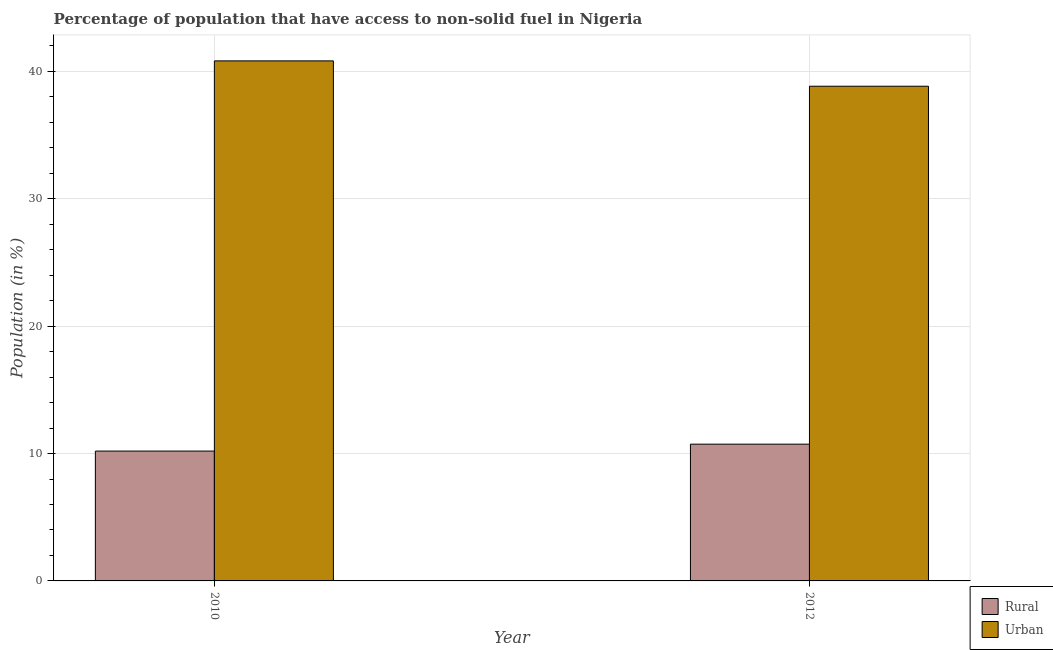How many groups of bars are there?
Your response must be concise. 2. Are the number of bars on each tick of the X-axis equal?
Ensure brevity in your answer.  Yes. In how many cases, is the number of bars for a given year not equal to the number of legend labels?
Keep it short and to the point. 0. What is the urban population in 2010?
Your response must be concise. 40.82. Across all years, what is the maximum rural population?
Give a very brief answer. 10.73. Across all years, what is the minimum urban population?
Make the answer very short. 38.83. What is the total rural population in the graph?
Offer a terse response. 20.93. What is the difference between the rural population in 2010 and that in 2012?
Give a very brief answer. -0.54. What is the difference between the rural population in 2012 and the urban population in 2010?
Provide a succinct answer. 0.54. What is the average urban population per year?
Offer a very short reply. 39.83. What is the ratio of the urban population in 2010 to that in 2012?
Provide a succinct answer. 1.05. Is the urban population in 2010 less than that in 2012?
Provide a succinct answer. No. In how many years, is the urban population greater than the average urban population taken over all years?
Provide a short and direct response. 1. What does the 2nd bar from the left in 2012 represents?
Keep it short and to the point. Urban. What does the 1st bar from the right in 2010 represents?
Your answer should be very brief. Urban. What is the difference between two consecutive major ticks on the Y-axis?
Your answer should be compact. 10. Are the values on the major ticks of Y-axis written in scientific E-notation?
Ensure brevity in your answer.  No. Does the graph contain any zero values?
Provide a short and direct response. No. Does the graph contain grids?
Make the answer very short. Yes. Where does the legend appear in the graph?
Your response must be concise. Bottom right. How many legend labels are there?
Make the answer very short. 2. How are the legend labels stacked?
Offer a terse response. Vertical. What is the title of the graph?
Keep it short and to the point. Percentage of population that have access to non-solid fuel in Nigeria. What is the label or title of the X-axis?
Offer a terse response. Year. What is the label or title of the Y-axis?
Keep it short and to the point. Population (in %). What is the Population (in %) in Rural in 2010?
Your answer should be very brief. 10.19. What is the Population (in %) in Urban in 2010?
Your answer should be very brief. 40.82. What is the Population (in %) of Rural in 2012?
Your answer should be compact. 10.73. What is the Population (in %) of Urban in 2012?
Provide a succinct answer. 38.83. Across all years, what is the maximum Population (in %) of Rural?
Offer a terse response. 10.73. Across all years, what is the maximum Population (in %) in Urban?
Keep it short and to the point. 40.82. Across all years, what is the minimum Population (in %) in Rural?
Ensure brevity in your answer.  10.19. Across all years, what is the minimum Population (in %) of Urban?
Make the answer very short. 38.83. What is the total Population (in %) in Rural in the graph?
Ensure brevity in your answer.  20.93. What is the total Population (in %) in Urban in the graph?
Make the answer very short. 79.65. What is the difference between the Population (in %) in Rural in 2010 and that in 2012?
Offer a very short reply. -0.54. What is the difference between the Population (in %) in Urban in 2010 and that in 2012?
Your answer should be very brief. 1.99. What is the difference between the Population (in %) in Rural in 2010 and the Population (in %) in Urban in 2012?
Make the answer very short. -28.64. What is the average Population (in %) of Rural per year?
Make the answer very short. 10.46. What is the average Population (in %) in Urban per year?
Give a very brief answer. 39.83. In the year 2010, what is the difference between the Population (in %) in Rural and Population (in %) in Urban?
Make the answer very short. -30.63. In the year 2012, what is the difference between the Population (in %) in Rural and Population (in %) in Urban?
Ensure brevity in your answer.  -28.1. What is the ratio of the Population (in %) in Rural in 2010 to that in 2012?
Keep it short and to the point. 0.95. What is the ratio of the Population (in %) of Urban in 2010 to that in 2012?
Keep it short and to the point. 1.05. What is the difference between the highest and the second highest Population (in %) in Rural?
Ensure brevity in your answer.  0.54. What is the difference between the highest and the second highest Population (in %) of Urban?
Your response must be concise. 1.99. What is the difference between the highest and the lowest Population (in %) of Rural?
Your response must be concise. 0.54. What is the difference between the highest and the lowest Population (in %) of Urban?
Ensure brevity in your answer.  1.99. 